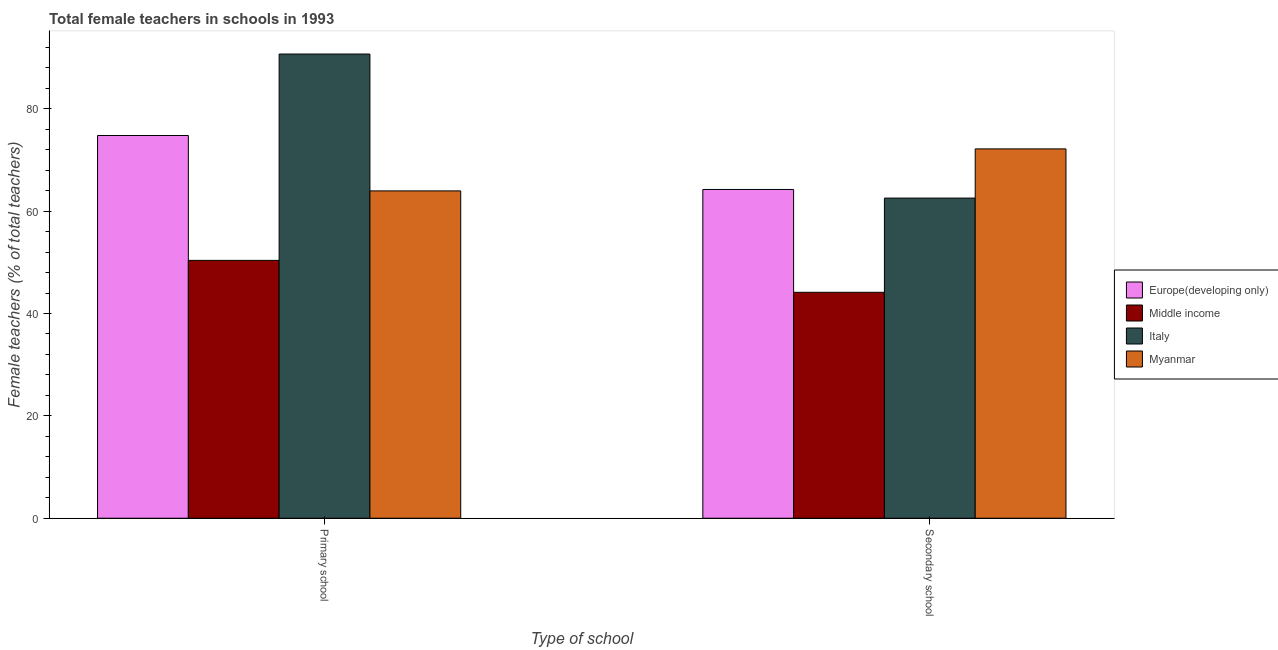How many different coloured bars are there?
Provide a short and direct response. 4. How many groups of bars are there?
Your response must be concise. 2. Are the number of bars per tick equal to the number of legend labels?
Ensure brevity in your answer.  Yes. How many bars are there on the 1st tick from the left?
Provide a succinct answer. 4. How many bars are there on the 2nd tick from the right?
Provide a succinct answer. 4. What is the label of the 1st group of bars from the left?
Ensure brevity in your answer.  Primary school. What is the percentage of female teachers in primary schools in Europe(developing only)?
Keep it short and to the point. 74.79. Across all countries, what is the maximum percentage of female teachers in primary schools?
Make the answer very short. 90.71. Across all countries, what is the minimum percentage of female teachers in primary schools?
Keep it short and to the point. 50.39. In which country was the percentage of female teachers in secondary schools maximum?
Offer a terse response. Myanmar. What is the total percentage of female teachers in secondary schools in the graph?
Your answer should be very brief. 243.11. What is the difference between the percentage of female teachers in primary schools in Italy and that in Myanmar?
Provide a succinct answer. 26.74. What is the difference between the percentage of female teachers in primary schools in Middle income and the percentage of female teachers in secondary schools in Europe(developing only)?
Your answer should be very brief. -13.86. What is the average percentage of female teachers in secondary schools per country?
Give a very brief answer. 60.78. What is the difference between the percentage of female teachers in secondary schools and percentage of female teachers in primary schools in Europe(developing only)?
Your answer should be very brief. -10.55. In how many countries, is the percentage of female teachers in secondary schools greater than 36 %?
Provide a short and direct response. 4. What is the ratio of the percentage of female teachers in secondary schools in Middle income to that in Myanmar?
Your response must be concise. 0.61. Is the percentage of female teachers in primary schools in Myanmar less than that in Europe(developing only)?
Offer a very short reply. Yes. What does the 4th bar from the left in Primary school represents?
Your response must be concise. Myanmar. What does the 4th bar from the right in Primary school represents?
Your response must be concise. Europe(developing only). How many bars are there?
Your response must be concise. 8. How many countries are there in the graph?
Give a very brief answer. 4. What is the difference between two consecutive major ticks on the Y-axis?
Ensure brevity in your answer.  20. Where does the legend appear in the graph?
Offer a terse response. Center right. How are the legend labels stacked?
Your response must be concise. Vertical. What is the title of the graph?
Your answer should be compact. Total female teachers in schools in 1993. What is the label or title of the X-axis?
Your response must be concise. Type of school. What is the label or title of the Y-axis?
Make the answer very short. Female teachers (% of total teachers). What is the Female teachers (% of total teachers) of Europe(developing only) in Primary school?
Provide a short and direct response. 74.79. What is the Female teachers (% of total teachers) of Middle income in Primary school?
Keep it short and to the point. 50.39. What is the Female teachers (% of total teachers) of Italy in Primary school?
Make the answer very short. 90.71. What is the Female teachers (% of total teachers) of Myanmar in Primary school?
Make the answer very short. 63.96. What is the Female teachers (% of total teachers) in Europe(developing only) in Secondary school?
Keep it short and to the point. 64.24. What is the Female teachers (% of total teachers) of Middle income in Secondary school?
Provide a succinct answer. 44.15. What is the Female teachers (% of total teachers) of Italy in Secondary school?
Keep it short and to the point. 62.56. What is the Female teachers (% of total teachers) in Myanmar in Secondary school?
Provide a succinct answer. 72.17. Across all Type of school, what is the maximum Female teachers (% of total teachers) in Europe(developing only)?
Provide a short and direct response. 74.79. Across all Type of school, what is the maximum Female teachers (% of total teachers) in Middle income?
Keep it short and to the point. 50.39. Across all Type of school, what is the maximum Female teachers (% of total teachers) of Italy?
Your response must be concise. 90.71. Across all Type of school, what is the maximum Female teachers (% of total teachers) in Myanmar?
Provide a succinct answer. 72.17. Across all Type of school, what is the minimum Female teachers (% of total teachers) of Europe(developing only)?
Your response must be concise. 64.24. Across all Type of school, what is the minimum Female teachers (% of total teachers) in Middle income?
Give a very brief answer. 44.15. Across all Type of school, what is the minimum Female teachers (% of total teachers) of Italy?
Keep it short and to the point. 62.56. Across all Type of school, what is the minimum Female teachers (% of total teachers) in Myanmar?
Keep it short and to the point. 63.96. What is the total Female teachers (% of total teachers) in Europe(developing only) in the graph?
Your answer should be very brief. 139.03. What is the total Female teachers (% of total teachers) in Middle income in the graph?
Offer a very short reply. 94.53. What is the total Female teachers (% of total teachers) of Italy in the graph?
Keep it short and to the point. 153.26. What is the total Female teachers (% of total teachers) in Myanmar in the graph?
Offer a terse response. 136.13. What is the difference between the Female teachers (% of total teachers) in Europe(developing only) in Primary school and that in Secondary school?
Provide a short and direct response. 10.55. What is the difference between the Female teachers (% of total teachers) of Middle income in Primary school and that in Secondary school?
Your answer should be compact. 6.24. What is the difference between the Female teachers (% of total teachers) in Italy in Primary school and that in Secondary school?
Give a very brief answer. 28.15. What is the difference between the Female teachers (% of total teachers) in Myanmar in Primary school and that in Secondary school?
Offer a very short reply. -8.21. What is the difference between the Female teachers (% of total teachers) of Europe(developing only) in Primary school and the Female teachers (% of total teachers) of Middle income in Secondary school?
Offer a terse response. 30.64. What is the difference between the Female teachers (% of total teachers) of Europe(developing only) in Primary school and the Female teachers (% of total teachers) of Italy in Secondary school?
Ensure brevity in your answer.  12.23. What is the difference between the Female teachers (% of total teachers) of Europe(developing only) in Primary school and the Female teachers (% of total teachers) of Myanmar in Secondary school?
Provide a short and direct response. 2.62. What is the difference between the Female teachers (% of total teachers) in Middle income in Primary school and the Female teachers (% of total teachers) in Italy in Secondary school?
Keep it short and to the point. -12.17. What is the difference between the Female teachers (% of total teachers) in Middle income in Primary school and the Female teachers (% of total teachers) in Myanmar in Secondary school?
Offer a terse response. -21.78. What is the difference between the Female teachers (% of total teachers) in Italy in Primary school and the Female teachers (% of total teachers) in Myanmar in Secondary school?
Make the answer very short. 18.54. What is the average Female teachers (% of total teachers) of Europe(developing only) per Type of school?
Provide a short and direct response. 69.51. What is the average Female teachers (% of total teachers) in Middle income per Type of school?
Ensure brevity in your answer.  47.27. What is the average Female teachers (% of total teachers) of Italy per Type of school?
Offer a terse response. 76.63. What is the average Female teachers (% of total teachers) of Myanmar per Type of school?
Ensure brevity in your answer.  68.06. What is the difference between the Female teachers (% of total teachers) in Europe(developing only) and Female teachers (% of total teachers) in Middle income in Primary school?
Provide a succinct answer. 24.4. What is the difference between the Female teachers (% of total teachers) of Europe(developing only) and Female teachers (% of total teachers) of Italy in Primary school?
Your answer should be very brief. -15.92. What is the difference between the Female teachers (% of total teachers) in Europe(developing only) and Female teachers (% of total teachers) in Myanmar in Primary school?
Keep it short and to the point. 10.83. What is the difference between the Female teachers (% of total teachers) in Middle income and Female teachers (% of total teachers) in Italy in Primary school?
Provide a succinct answer. -40.32. What is the difference between the Female teachers (% of total teachers) of Middle income and Female teachers (% of total teachers) of Myanmar in Primary school?
Provide a succinct answer. -13.58. What is the difference between the Female teachers (% of total teachers) of Italy and Female teachers (% of total teachers) of Myanmar in Primary school?
Ensure brevity in your answer.  26.74. What is the difference between the Female teachers (% of total teachers) in Europe(developing only) and Female teachers (% of total teachers) in Middle income in Secondary school?
Offer a very short reply. 20.1. What is the difference between the Female teachers (% of total teachers) of Europe(developing only) and Female teachers (% of total teachers) of Italy in Secondary school?
Make the answer very short. 1.68. What is the difference between the Female teachers (% of total teachers) in Europe(developing only) and Female teachers (% of total teachers) in Myanmar in Secondary school?
Keep it short and to the point. -7.93. What is the difference between the Female teachers (% of total teachers) in Middle income and Female teachers (% of total teachers) in Italy in Secondary school?
Your answer should be very brief. -18.41. What is the difference between the Female teachers (% of total teachers) in Middle income and Female teachers (% of total teachers) in Myanmar in Secondary school?
Offer a terse response. -28.02. What is the difference between the Female teachers (% of total teachers) of Italy and Female teachers (% of total teachers) of Myanmar in Secondary school?
Ensure brevity in your answer.  -9.61. What is the ratio of the Female teachers (% of total teachers) of Europe(developing only) in Primary school to that in Secondary school?
Your answer should be very brief. 1.16. What is the ratio of the Female teachers (% of total teachers) in Middle income in Primary school to that in Secondary school?
Give a very brief answer. 1.14. What is the ratio of the Female teachers (% of total teachers) in Italy in Primary school to that in Secondary school?
Offer a very short reply. 1.45. What is the ratio of the Female teachers (% of total teachers) of Myanmar in Primary school to that in Secondary school?
Ensure brevity in your answer.  0.89. What is the difference between the highest and the second highest Female teachers (% of total teachers) of Europe(developing only)?
Provide a succinct answer. 10.55. What is the difference between the highest and the second highest Female teachers (% of total teachers) in Middle income?
Provide a short and direct response. 6.24. What is the difference between the highest and the second highest Female teachers (% of total teachers) of Italy?
Give a very brief answer. 28.15. What is the difference between the highest and the second highest Female teachers (% of total teachers) in Myanmar?
Keep it short and to the point. 8.21. What is the difference between the highest and the lowest Female teachers (% of total teachers) in Europe(developing only)?
Offer a very short reply. 10.55. What is the difference between the highest and the lowest Female teachers (% of total teachers) in Middle income?
Your answer should be very brief. 6.24. What is the difference between the highest and the lowest Female teachers (% of total teachers) of Italy?
Keep it short and to the point. 28.15. What is the difference between the highest and the lowest Female teachers (% of total teachers) in Myanmar?
Make the answer very short. 8.21. 